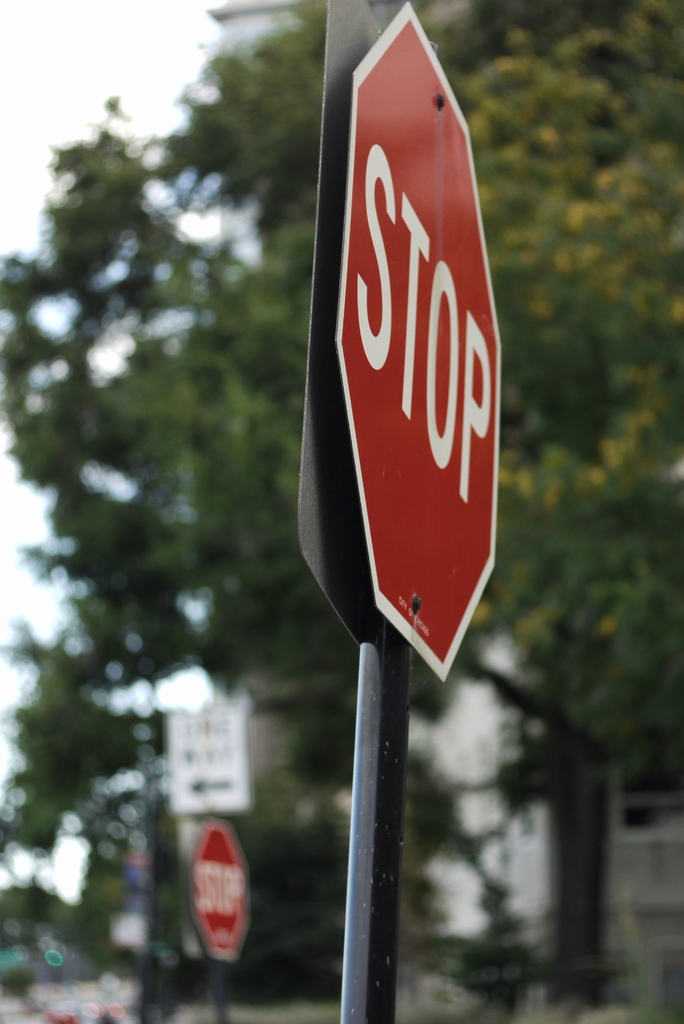What time of day does this photo appear to be taken? Based on the soft lighting and the absence of harsh shadows, it appears the photo was taken on an overcast day, possibly in the late morning or early afternoon when the light is diffuse, and the brightness is even. This kind of lighting is conducive to the calm mood the image evokes. 